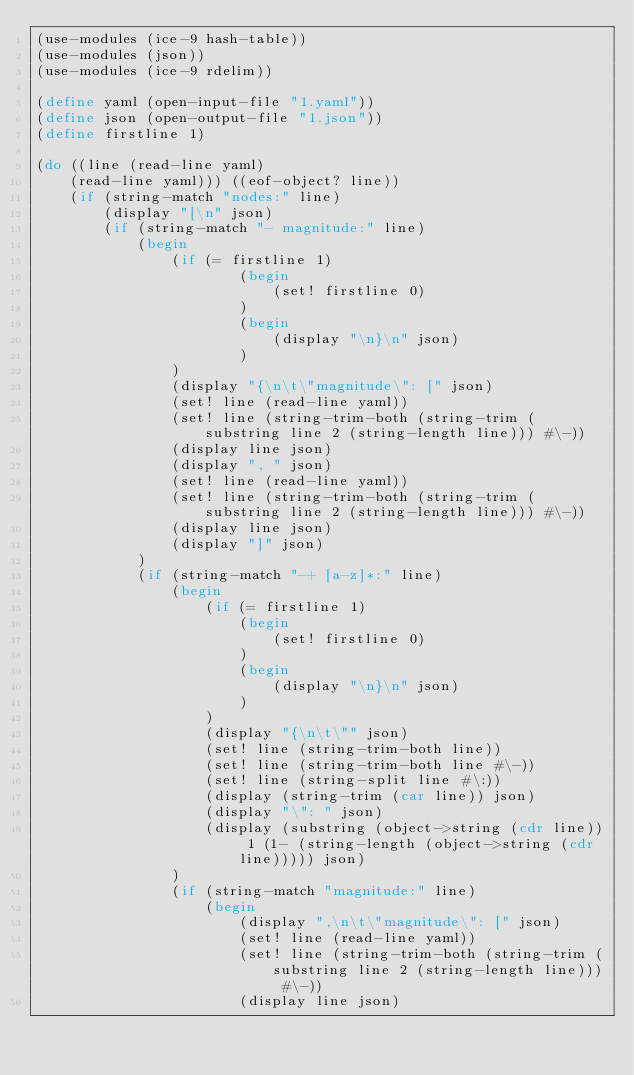Convert code to text. <code><loc_0><loc_0><loc_500><loc_500><_Scheme_>(use-modules (ice-9 hash-table))
(use-modules (json))
(use-modules (ice-9 rdelim))

(define yaml (open-input-file "1.yaml"))
(define json (open-output-file "1.json"))
(define firstline 1)

(do ((line (read-line yaml) 
	(read-line yaml))) ((eof-object? line))
	(if (string-match "nodes:" line)
		(display "[\n" json)
		(if (string-match "- magnitude:" line)
			(begin
				(if (= firstline 1)
						(begin
							(set! firstline 0)
						)
						(begin
							(display "\n}\n" json)
						)
				)
				(display "{\n\t\"magnitude\": [" json)
				(set! line (read-line yaml))
				(set! line (string-trim-both (string-trim (substring line 2 (string-length line))) #\-))
				(display line json)
				(display ", " json)
				(set! line (read-line yaml))
				(set! line (string-trim-both (string-trim (substring line 2 (string-length line))) #\-))
				(display line json)
				(display "]" json)
			)
			(if (string-match "-+ [a-z]*:" line)
				(begin
					(if (= firstline 1)
						(begin
							(set! firstline 0)
						)
						(begin
							(display "\n}\n" json)
						)
					)
					(display "{\n\t\"" json)
					(set! line (string-trim-both line))
					(set! line (string-trim-both line #\-))
					(set! line (string-split line #\:))
					(display (string-trim (car line)) json)
					(display "\": " json)
					(display (substring (object->string (cdr line)) 1 (1- (string-length (object->string (cdr line))))) json)
				)
				(if (string-match "magnitude:" line)
					(begin
						(display ",\n\t\"magnitude\": [" json)
						(set! line (read-line yaml))
						(set! line (string-trim-both (string-trim (substring line 2 (string-length line))) #\-))
						(display line json)</code> 